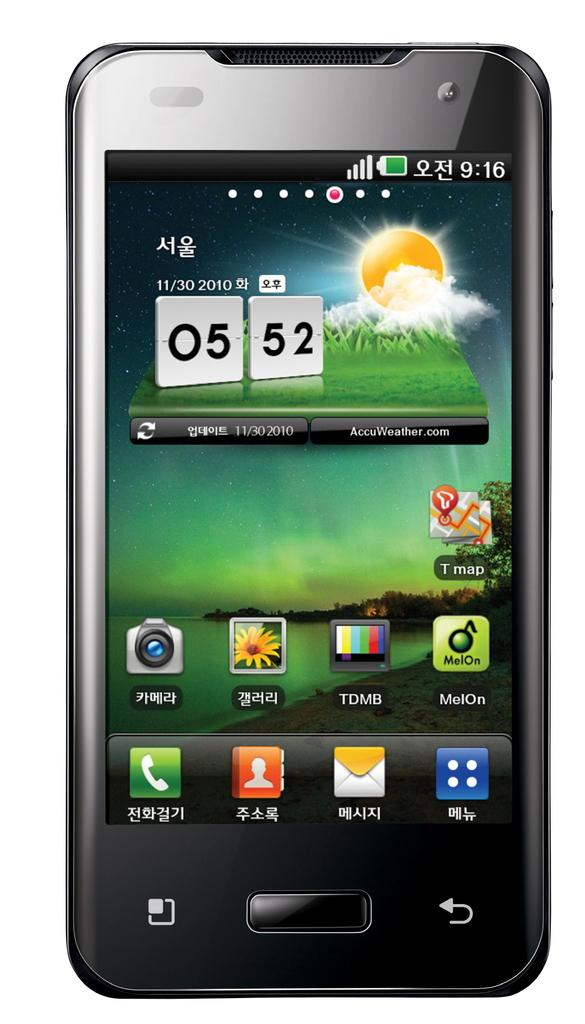What is the main object in the image? There is a mobile in the image. What type of pets can be seen playing with the mobile in the image? There are no pets present in the image, and the mobile is not being played with. What type of music is being played in the background of the image? There is no music present in the image. 